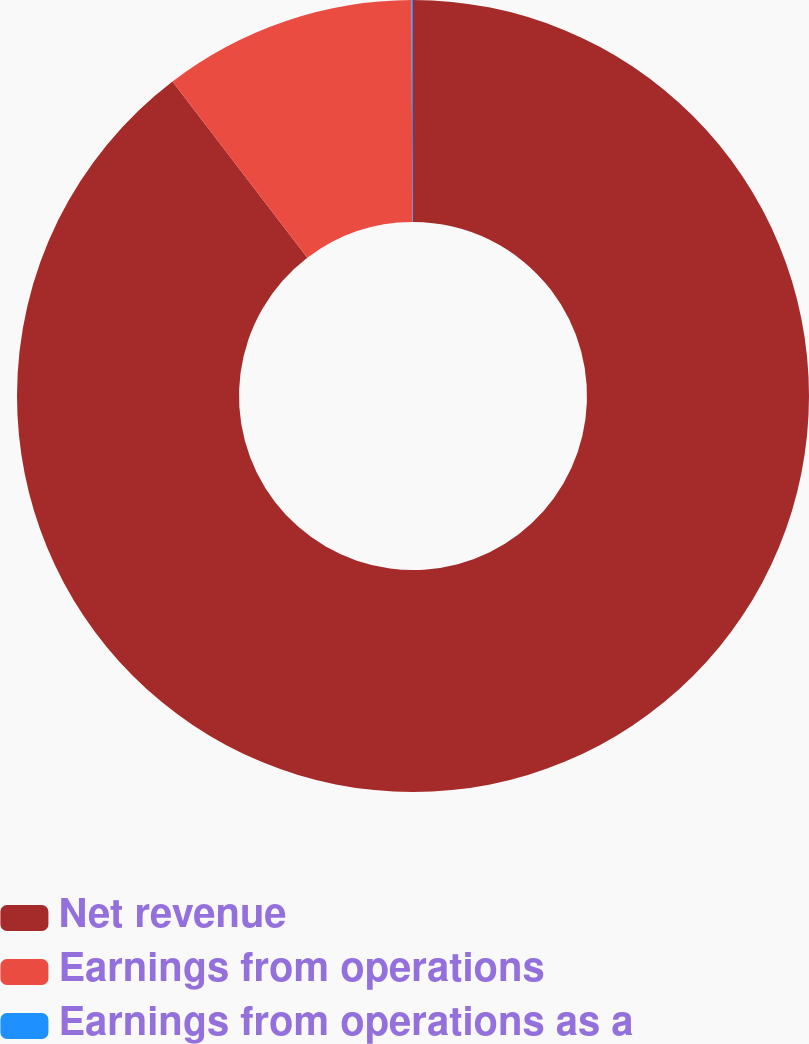Convert chart to OTSL. <chart><loc_0><loc_0><loc_500><loc_500><pie_chart><fcel>Net revenue<fcel>Earnings from operations<fcel>Earnings from operations as a<nl><fcel>89.62%<fcel>10.33%<fcel>0.06%<nl></chart> 